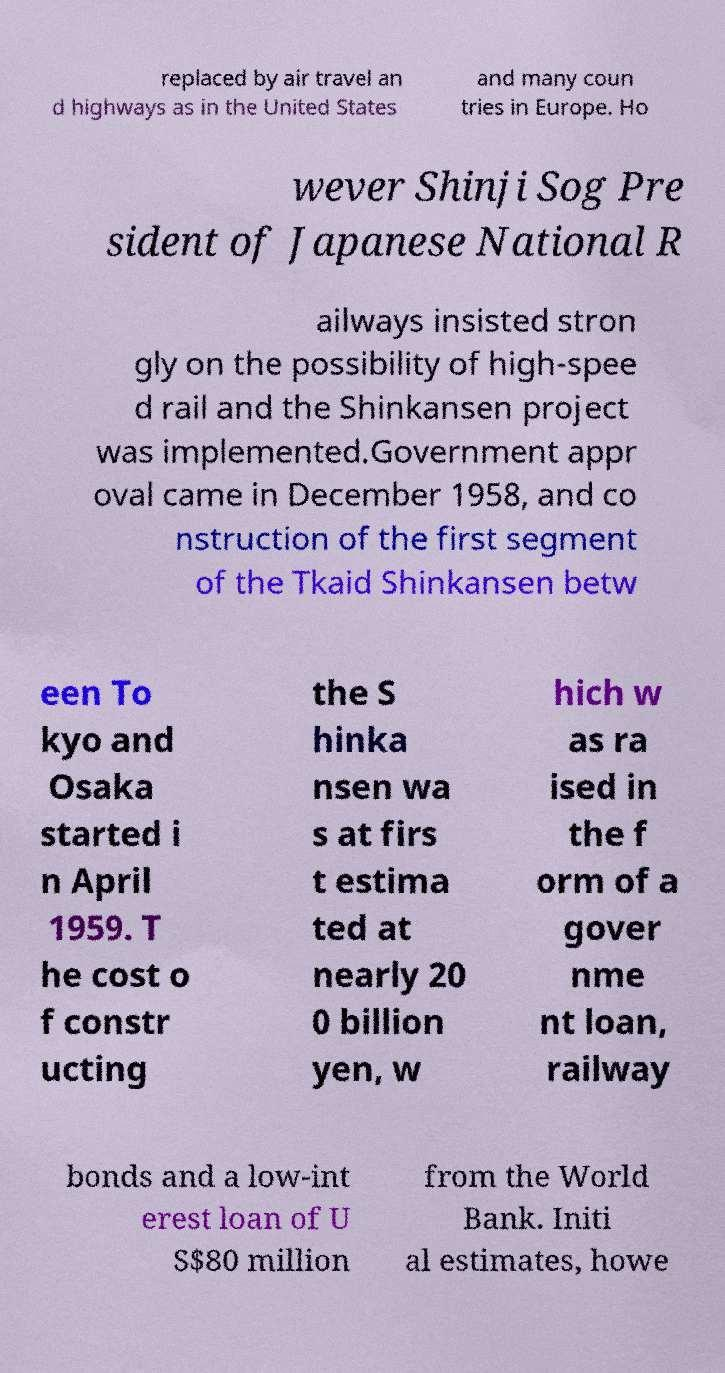Please read and relay the text visible in this image. What does it say? replaced by air travel an d highways as in the United States and many coun tries in Europe. Ho wever Shinji Sog Pre sident of Japanese National R ailways insisted stron gly on the possibility of high-spee d rail and the Shinkansen project was implemented.Government appr oval came in December 1958, and co nstruction of the first segment of the Tkaid Shinkansen betw een To kyo and Osaka started i n April 1959. T he cost o f constr ucting the S hinka nsen wa s at firs t estima ted at nearly 20 0 billion yen, w hich w as ra ised in the f orm of a gover nme nt loan, railway bonds and a low-int erest loan of U S$80 million from the World Bank. Initi al estimates, howe 